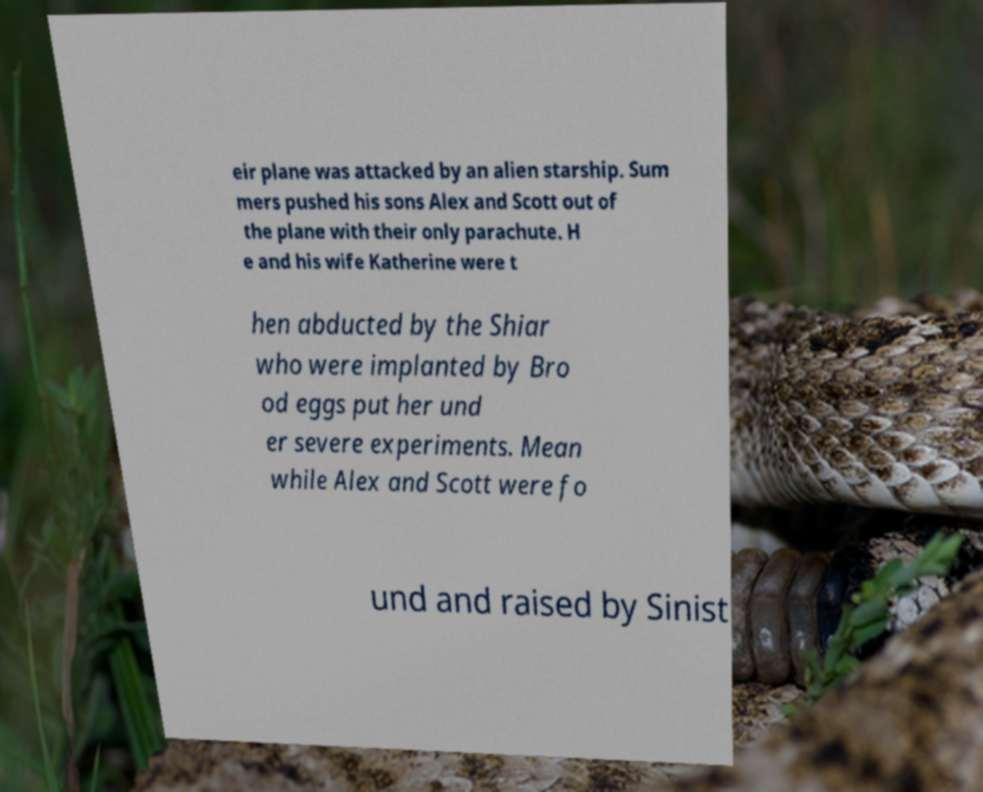For documentation purposes, I need the text within this image transcribed. Could you provide that? eir plane was attacked by an alien starship. Sum mers pushed his sons Alex and Scott out of the plane with their only parachute. H e and his wife Katherine were t hen abducted by the Shiar who were implanted by Bro od eggs put her und er severe experiments. Mean while Alex and Scott were fo und and raised by Sinist 